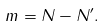Convert formula to latex. <formula><loc_0><loc_0><loc_500><loc_500>m = N - N ^ { \prime } .</formula> 